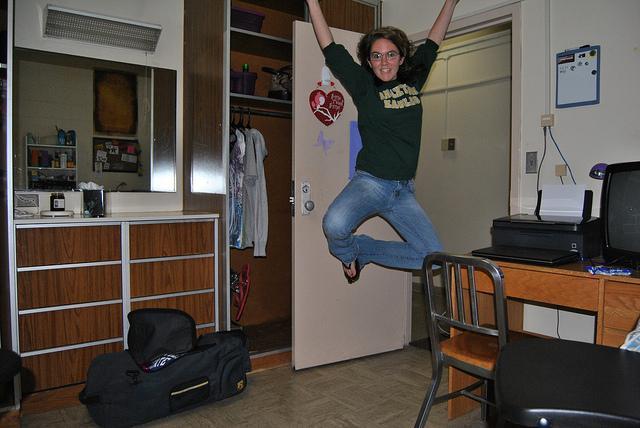Where is the woman jumping?
Pick the right solution, then justify: 'Answer: answer
Rationale: rationale.'
Options: Dorm room, hotel room, restaurant, hospital room. Answer: dorm room.
Rationale: The room is personalized and everything is in a small area 